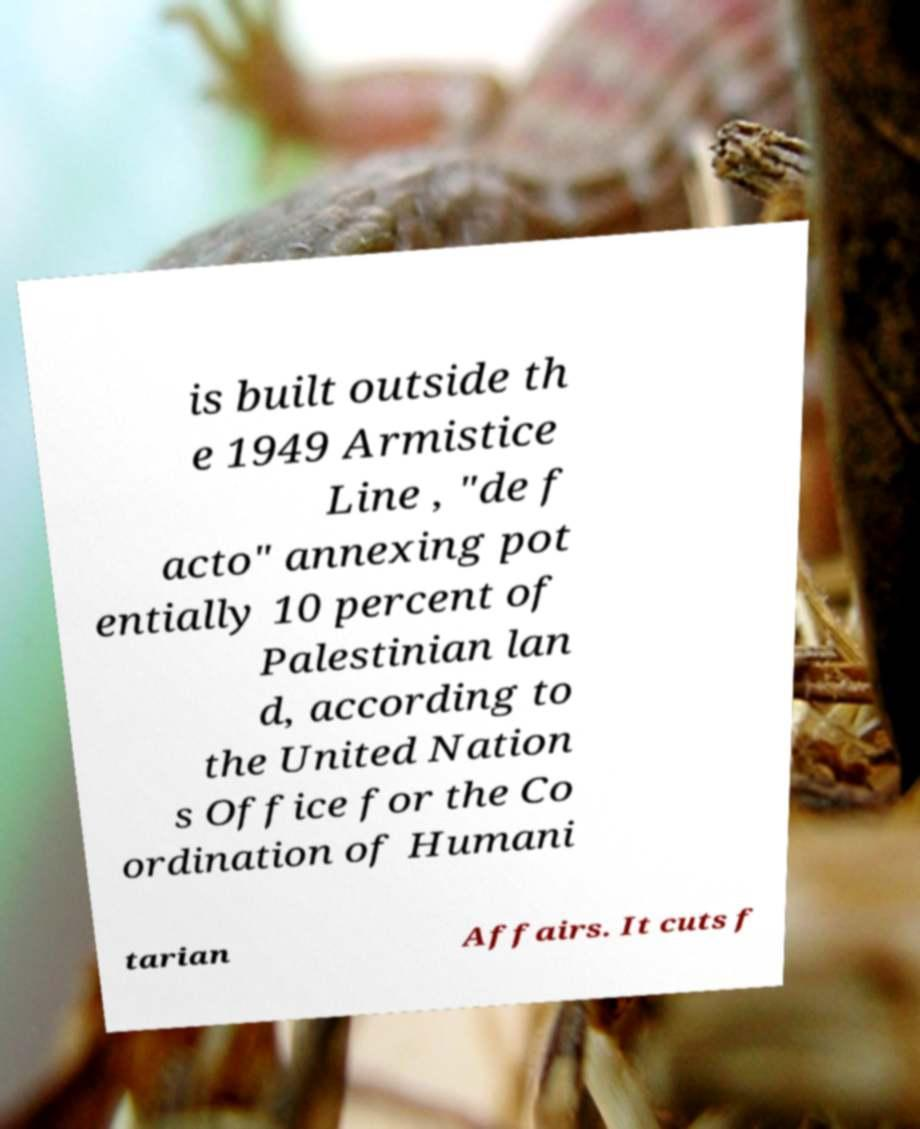I need the written content from this picture converted into text. Can you do that? is built outside th e 1949 Armistice Line , "de f acto" annexing pot entially 10 percent of Palestinian lan d, according to the United Nation s Office for the Co ordination of Humani tarian Affairs. It cuts f 